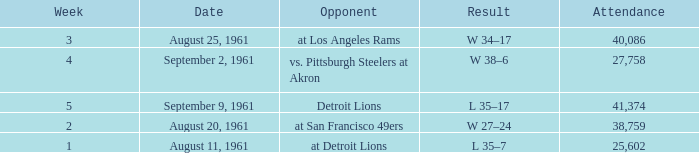What was the score of the Browns week 4 game? W 38–6. 